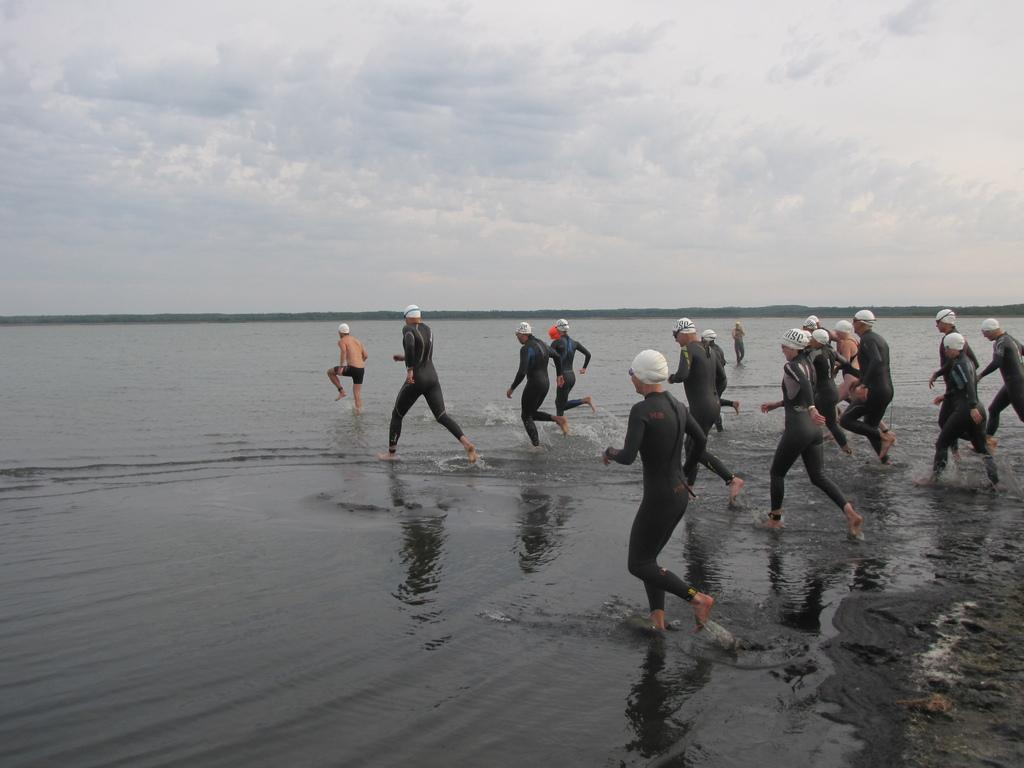What are the people in the image doing? The people in the image are running. What are the people wearing on their heads? The people are wearing caps. What can be seen in the image besides the people running? There is water visible in the image. What is visible in the background of the image? There is: There is sky with clouds in the background of the image. What type of needle is the daughter using to sew a paper in the image? There is no daughter, needle, or paper present in the image. 